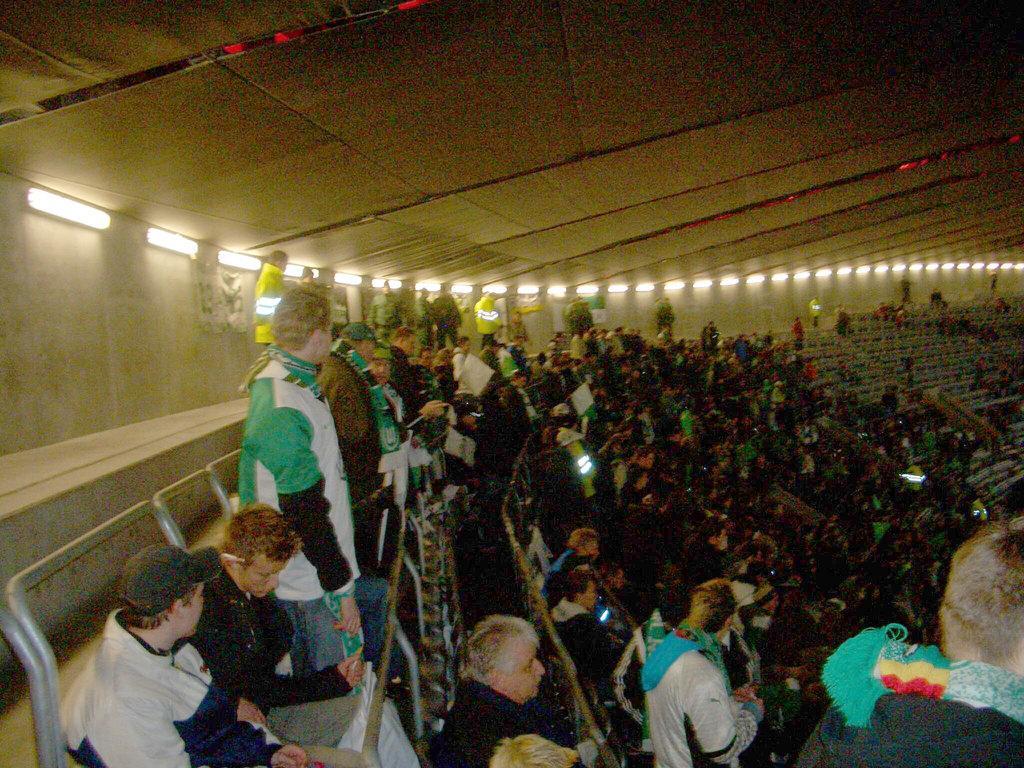How would you summarize this image in a sentence or two? There is a crowd. Some people are sitting and some people are standing. On the ceiling there are lights. 